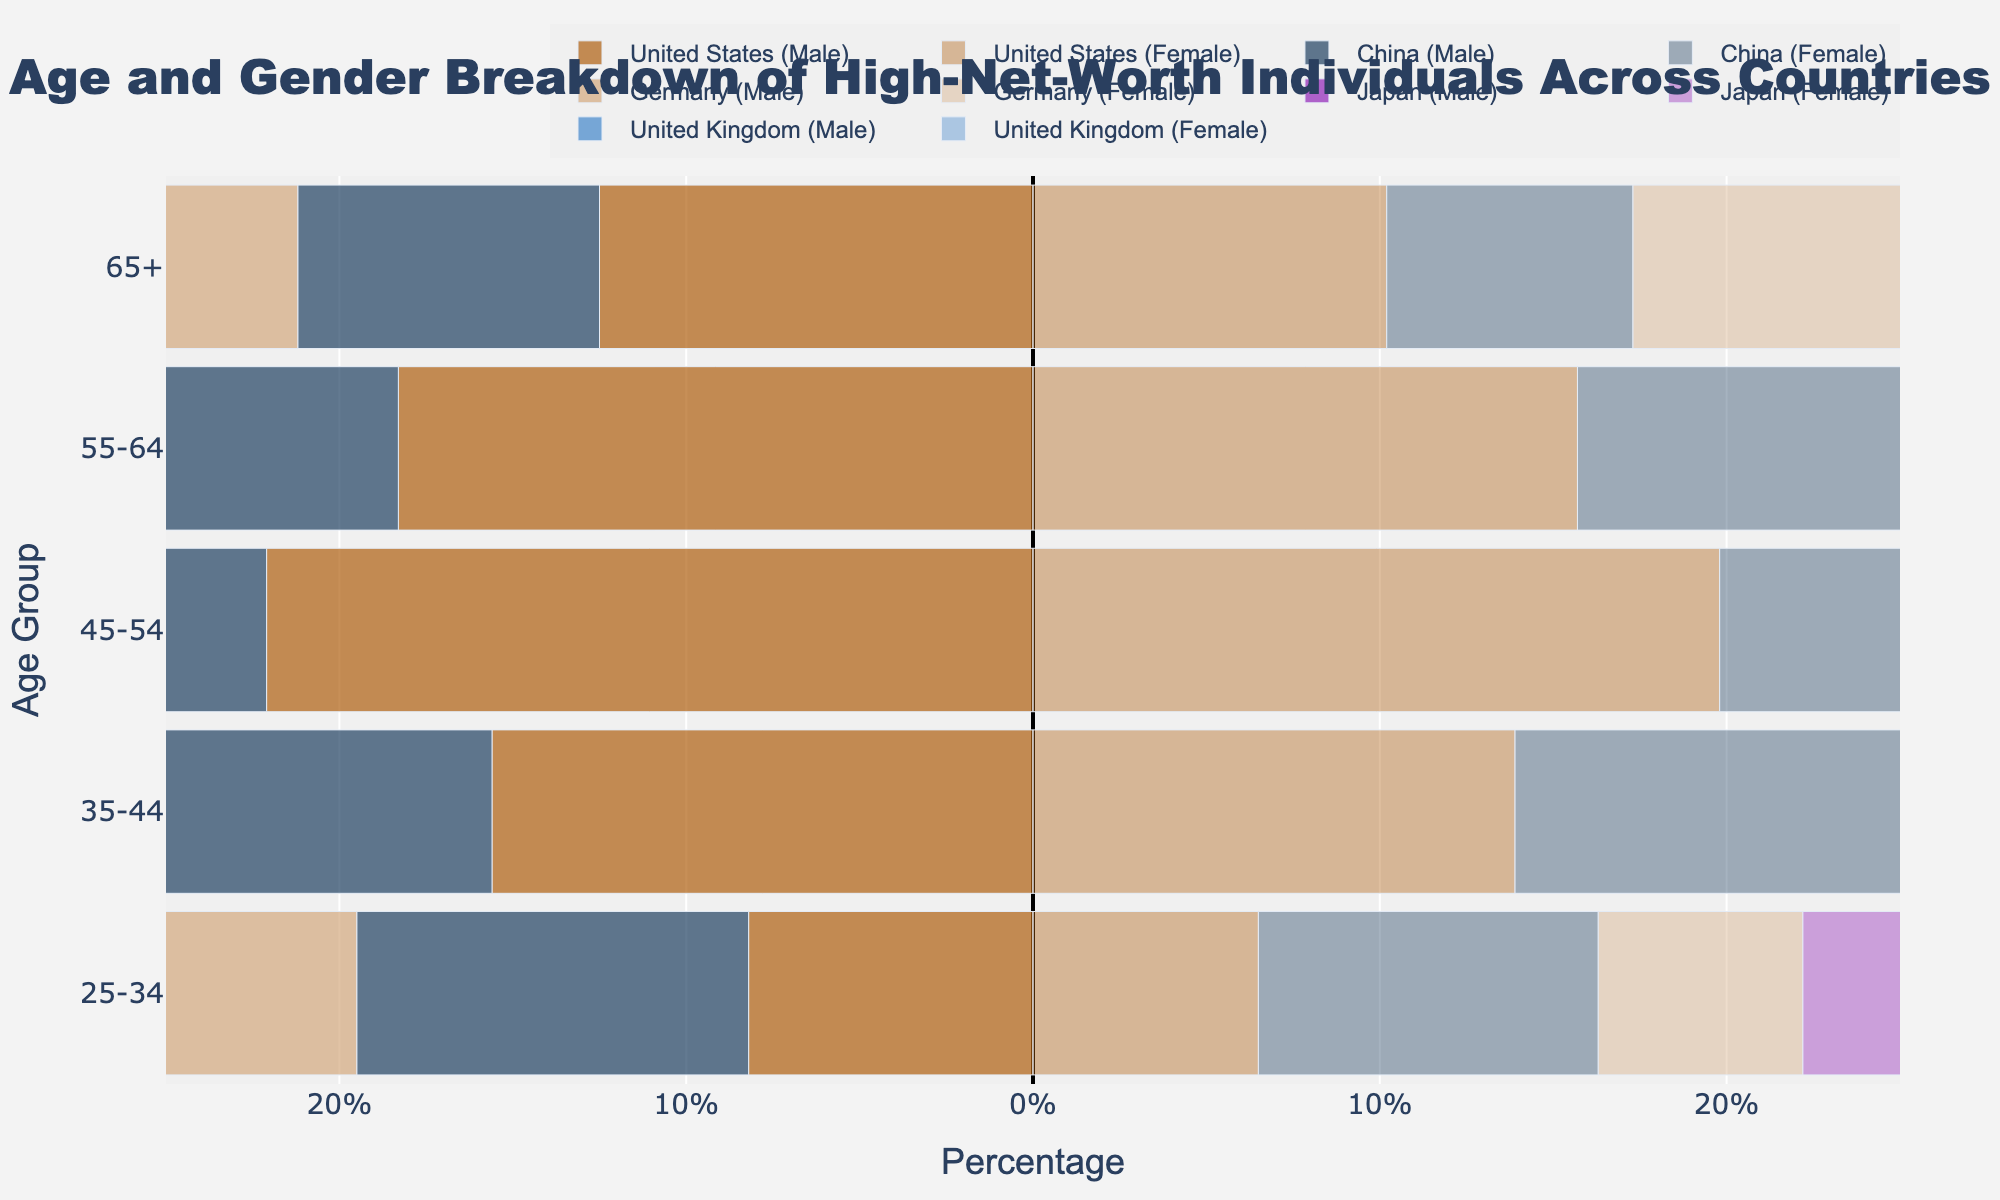What is the title of the figure? The title of the figure is prominently displayed at the top. Simply reading it will yield the answer.
Answer: Age and Gender Breakdown of High-Net-Worth Individuals Across Countries What is the largest percentage value for males in the 45-54 age group? Look for the longest bar that represents males in the 45-54 age group and read the corresponding percentage value from the x-axis.
Answer: 24.5% Which country has the highest percentage of high-net-worth individuals in the 25-34 age group? Compare the lengths of the bars for both males and females across countries in the 25-34 age group, and identify the country with the longest combined bar.
Answer: China Which country shows the least disparity between males and females in the 65+ age group? Evaluate the difference in lengths between the male and female bars for each country in the 65+ age group, and identify the country with the smallest difference.
Answer: China Across all countries, who has a higher percentage in the 55-64 age group, males or females? Sum up the length of bars for males and females in the 55-64 age group across all countries and compare the totals.
Answer: Males What is the percentage difference between males and females in the 35-44 age group in Japan? Subtract the percentage of females from males in the 35-44 age group specifically for Japan.
Answer: 2.2% Which country has the smallest number of high-net-worth individuals in the 25-34 age group (considering both genders)? Observe the lengths of bars in the 25-34 age group for both genders in each country, and pick the smallest.
Answer: Japan How does the male percentage in Germany's 55-64 age group compare to that of the United States? Compare the lengths of the bars for males in the 55-64 age group for Germany and the United States.
Answer: Germany is higher In the United Kingdom, which age group has the highest percentage of females? Identify the longest bar for females specifically for each age group in the United Kingdom.
Answer: 45-54 Which age group in China has the highest representation of high-net-worth individuals? Look for the age group with the longest combined (male and female) bars in China.
Answer: 45-54 